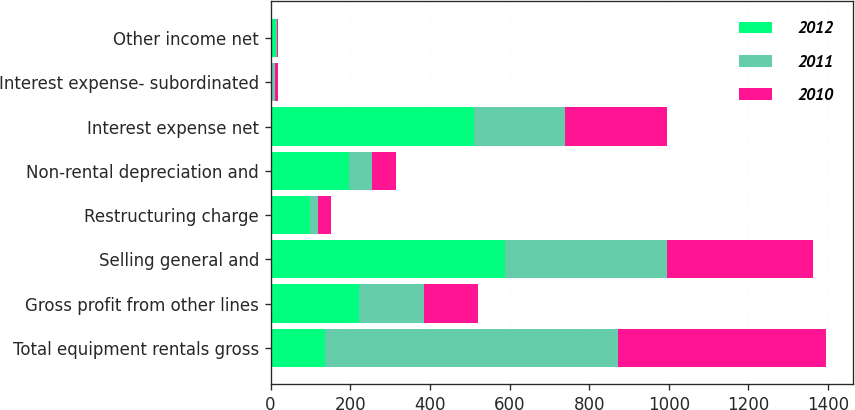Convert chart. <chart><loc_0><loc_0><loc_500><loc_500><stacked_bar_chart><ecel><fcel>Total equipment rentals gross<fcel>Gross profit from other lines<fcel>Selling general and<fcel>Restructuring charge<fcel>Non-rental depreciation and<fcel>Interest expense net<fcel>Interest expense- subordinated<fcel>Other income net<nl><fcel>2012<fcel>137<fcel>223<fcel>588<fcel>99<fcel>198<fcel>512<fcel>4<fcel>13<nl><fcel>2011<fcel>736<fcel>162<fcel>407<fcel>19<fcel>57<fcel>228<fcel>7<fcel>3<nl><fcel>2010<fcel>521<fcel>137<fcel>367<fcel>34<fcel>60<fcel>255<fcel>8<fcel>3<nl></chart> 